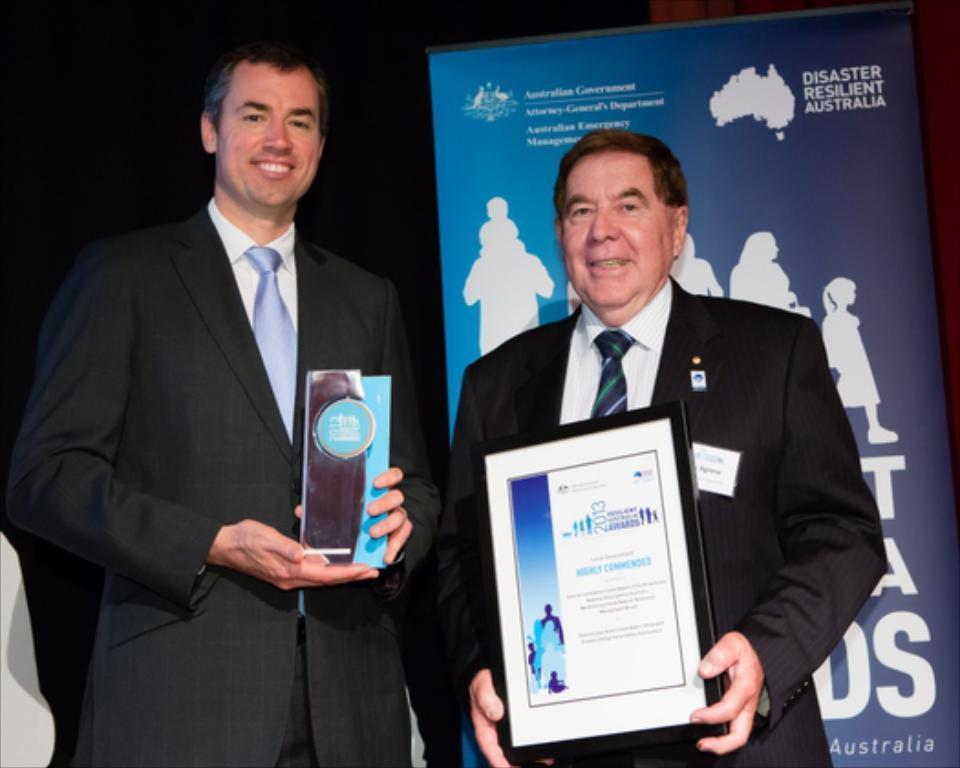Describe this image in one or two sentences. In this image there are two men who are standing by holding the mementos. In the background there is a banner. They are wearing the black color suit. 